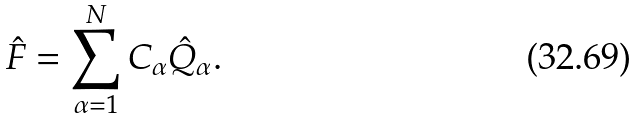<formula> <loc_0><loc_0><loc_500><loc_500>\hat { F } = \sum _ { \alpha = 1 } ^ { N } C _ { \alpha } \hat { Q } _ { \alpha } .</formula> 